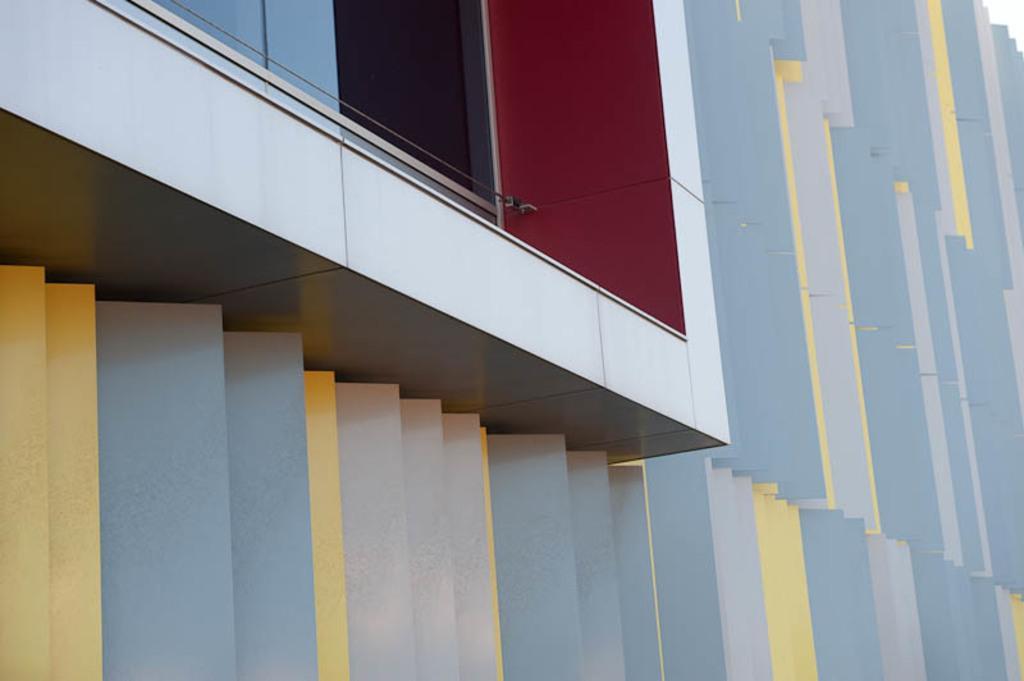Describe this image in one or two sentences. In this picture we can see a building here, at the left top we can see a glass window. 